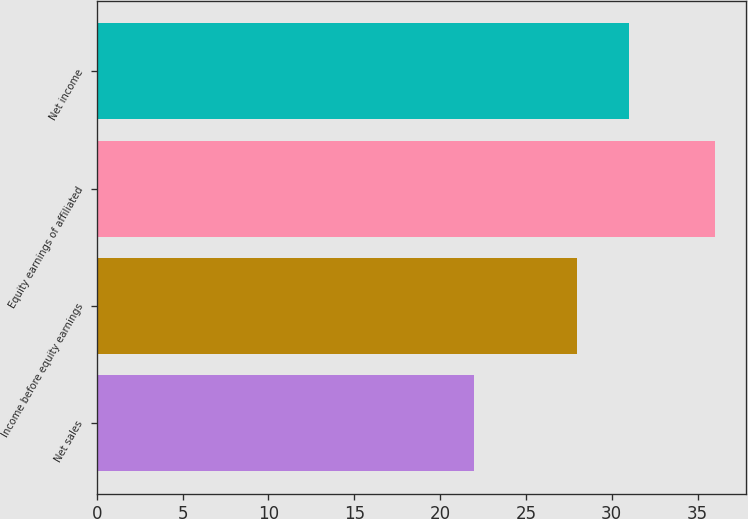<chart> <loc_0><loc_0><loc_500><loc_500><bar_chart><fcel>Net sales<fcel>Income before equity earnings<fcel>Equity earnings of affiliated<fcel>Net income<nl><fcel>22<fcel>28<fcel>36<fcel>31<nl></chart> 